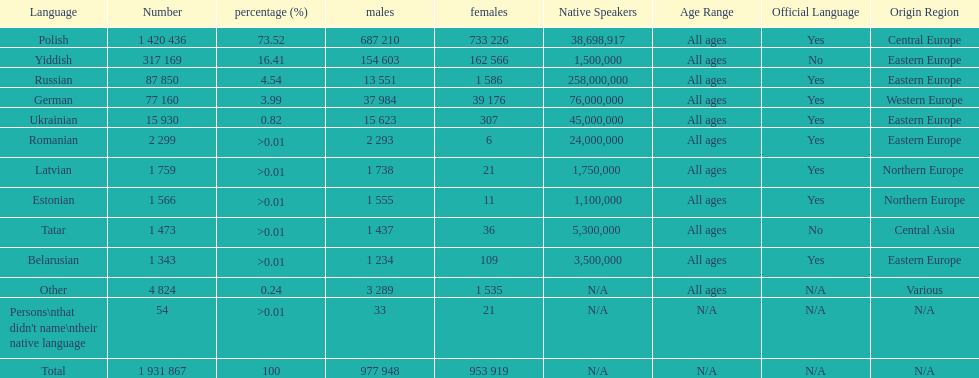What was the top language from the one's whose percentage was >0.01 Romanian. 